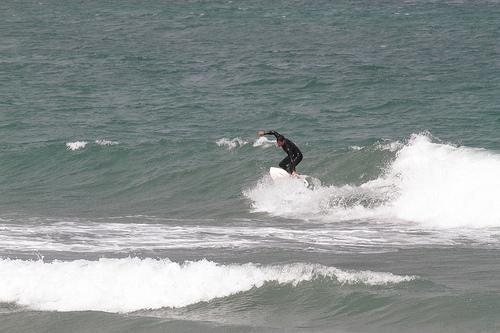How many people are pictured here?
Give a very brief answer. 1. 